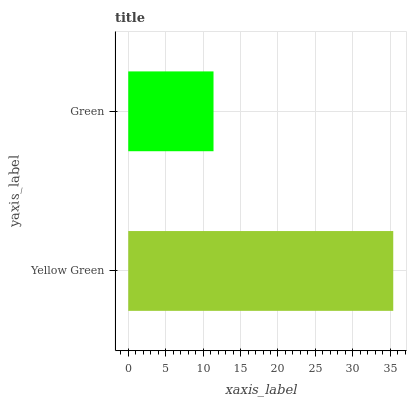Is Green the minimum?
Answer yes or no. Yes. Is Yellow Green the maximum?
Answer yes or no. Yes. Is Green the maximum?
Answer yes or no. No. Is Yellow Green greater than Green?
Answer yes or no. Yes. Is Green less than Yellow Green?
Answer yes or no. Yes. Is Green greater than Yellow Green?
Answer yes or no. No. Is Yellow Green less than Green?
Answer yes or no. No. Is Yellow Green the high median?
Answer yes or no. Yes. Is Green the low median?
Answer yes or no. Yes. Is Green the high median?
Answer yes or no. No. Is Yellow Green the low median?
Answer yes or no. No. 